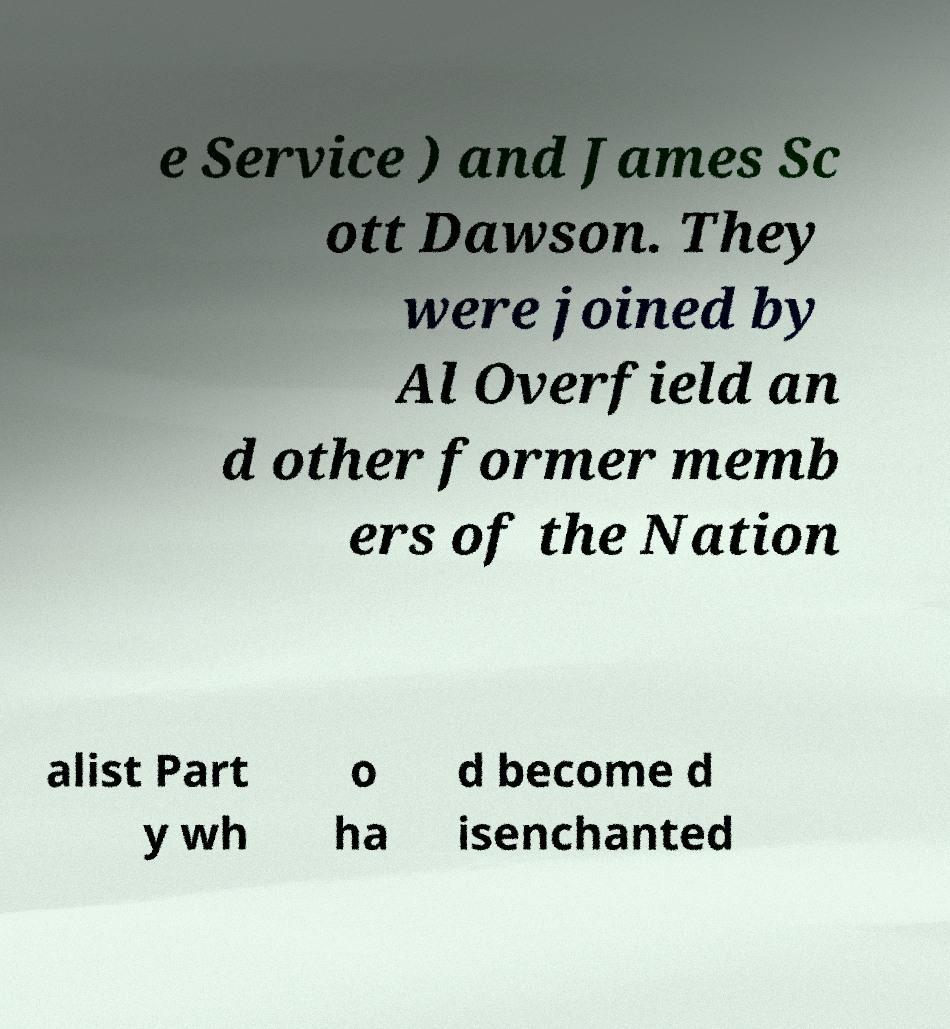What messages or text are displayed in this image? I need them in a readable, typed format. e Service ) and James Sc ott Dawson. They were joined by Al Overfield an d other former memb ers of the Nation alist Part y wh o ha d become d isenchanted 